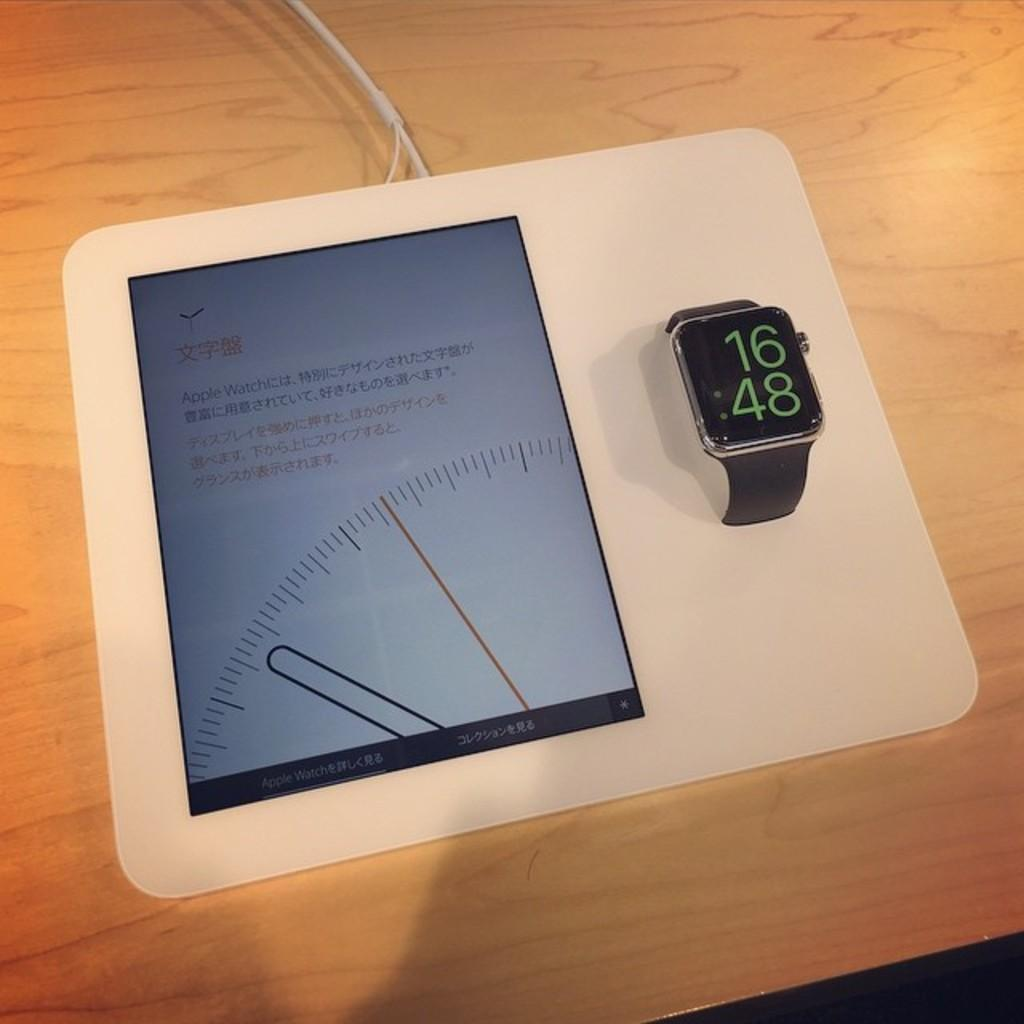<image>
Present a compact description of the photo's key features. A black watch shows the time at "16:48". 